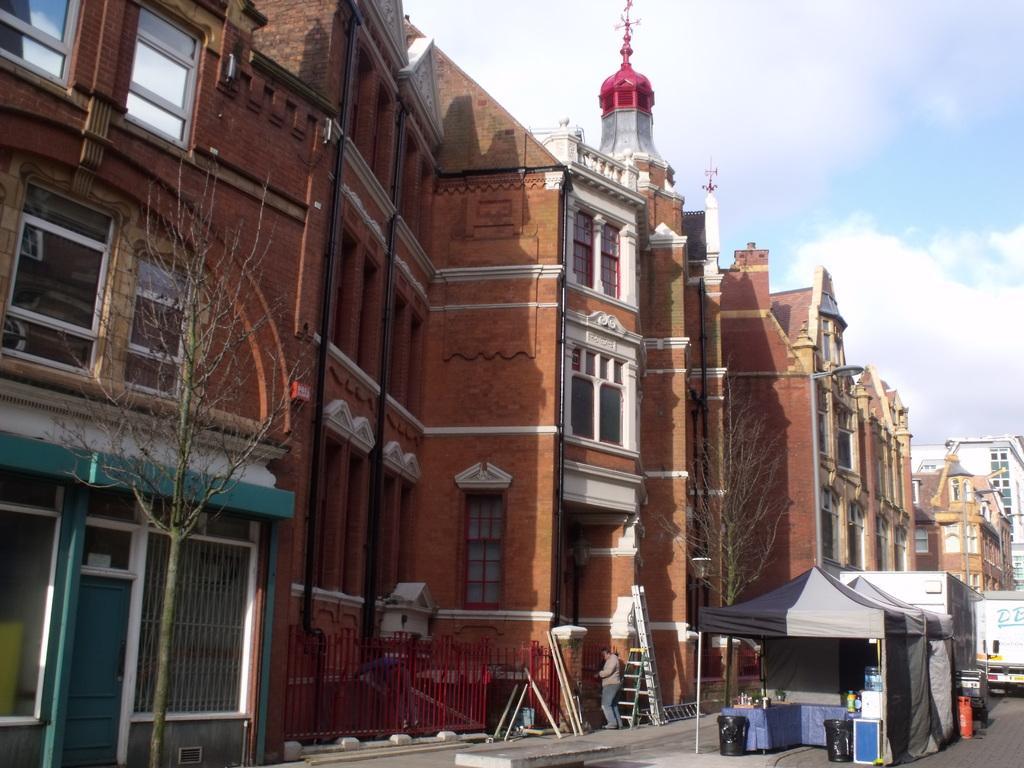Could you give a brief overview of what you see in this image? This picture is clicked outside. On the right we can see the tents and the vehicles and a cylinder like object is placed on the ground, we can see the tables on the top of which some objects are placed and we can see some objects are placed on the ground. On the left we can see the ladders and a person standing on the ground and we can see the buildings, trees and the metal rods and the bamboo and some other objects. In the background we can see the sky with the clouds and we can see the dome and the buildings. 